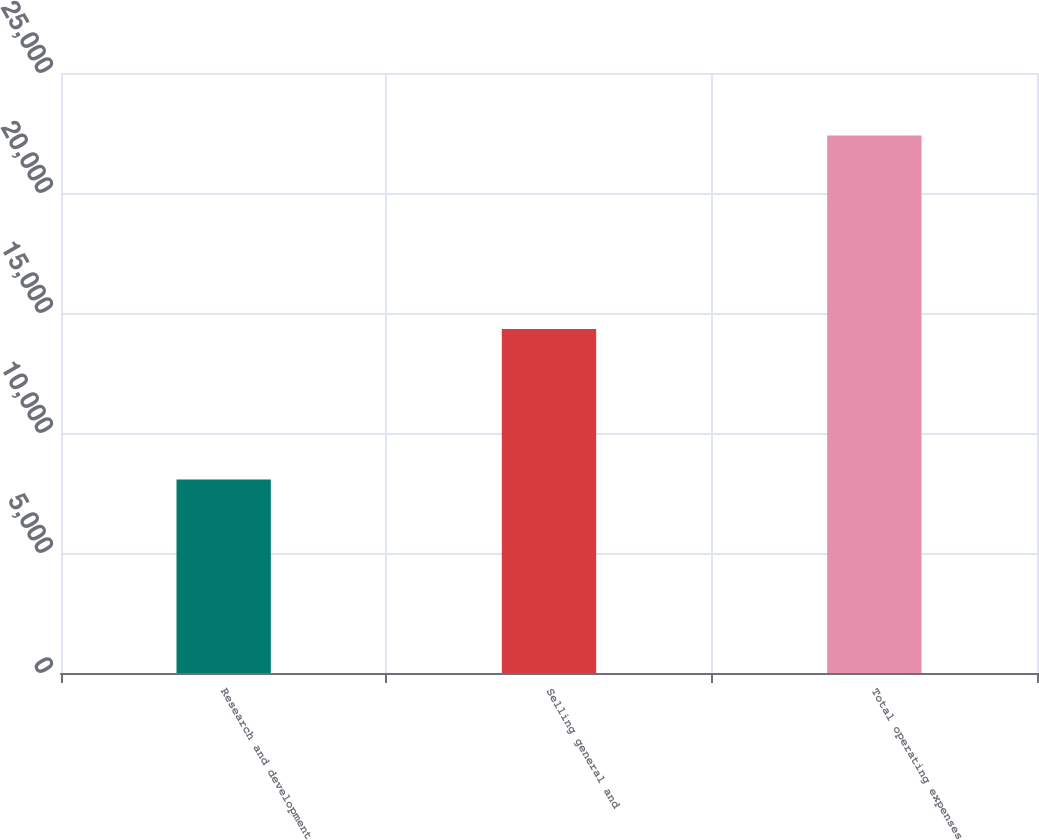Convert chart to OTSL. <chart><loc_0><loc_0><loc_500><loc_500><bar_chart><fcel>Research and development<fcel>Selling general and<fcel>Total operating expenses<nl><fcel>8067<fcel>14329<fcel>22396<nl></chart> 